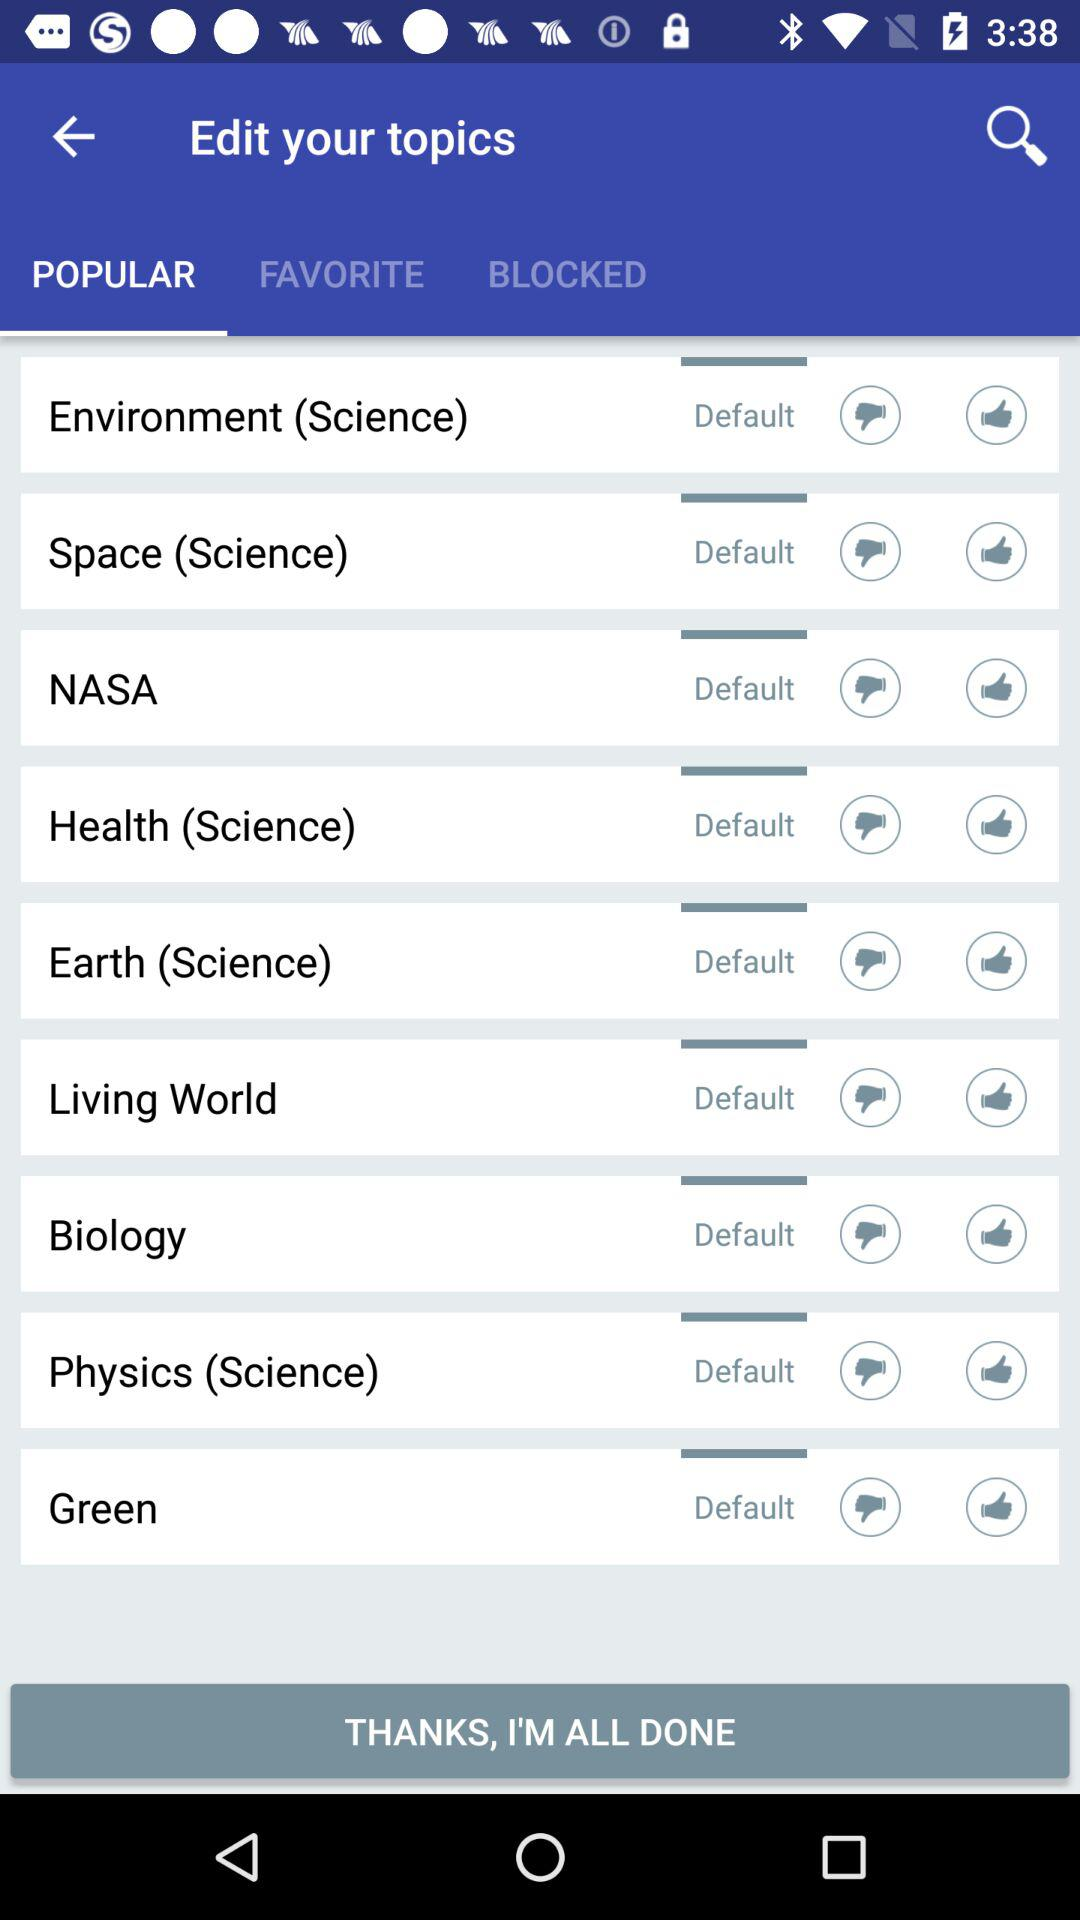What are some of the popular topics? Some of the popular topics are Environment (Science), Space (Science), NASA, Health (Science), Earth (Science), Living World, Biology, Physics (Science) and Green. 